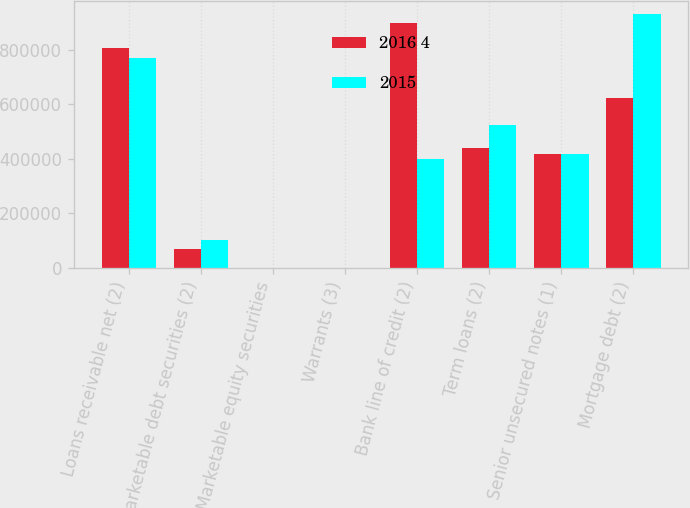<chart> <loc_0><loc_0><loc_500><loc_500><stacked_bar_chart><ecel><fcel>Loans receivable net (2)<fcel>Marketable debt securities (2)<fcel>Marketable equity securities<fcel>Warrants (3)<fcel>Bank line of credit (2)<fcel>Term loans (2)<fcel>Senior unsecured notes (1)<fcel>Mortgage debt (2)<nl><fcel>2016 4<fcel>807954<fcel>68630<fcel>76<fcel>19<fcel>899718<fcel>440062<fcel>418747<fcel>623792<nl><fcel>2015<fcel>768743<fcel>102958<fcel>39<fcel>55<fcel>397432<fcel>524807<fcel>418747<fcel>932212<nl></chart> 